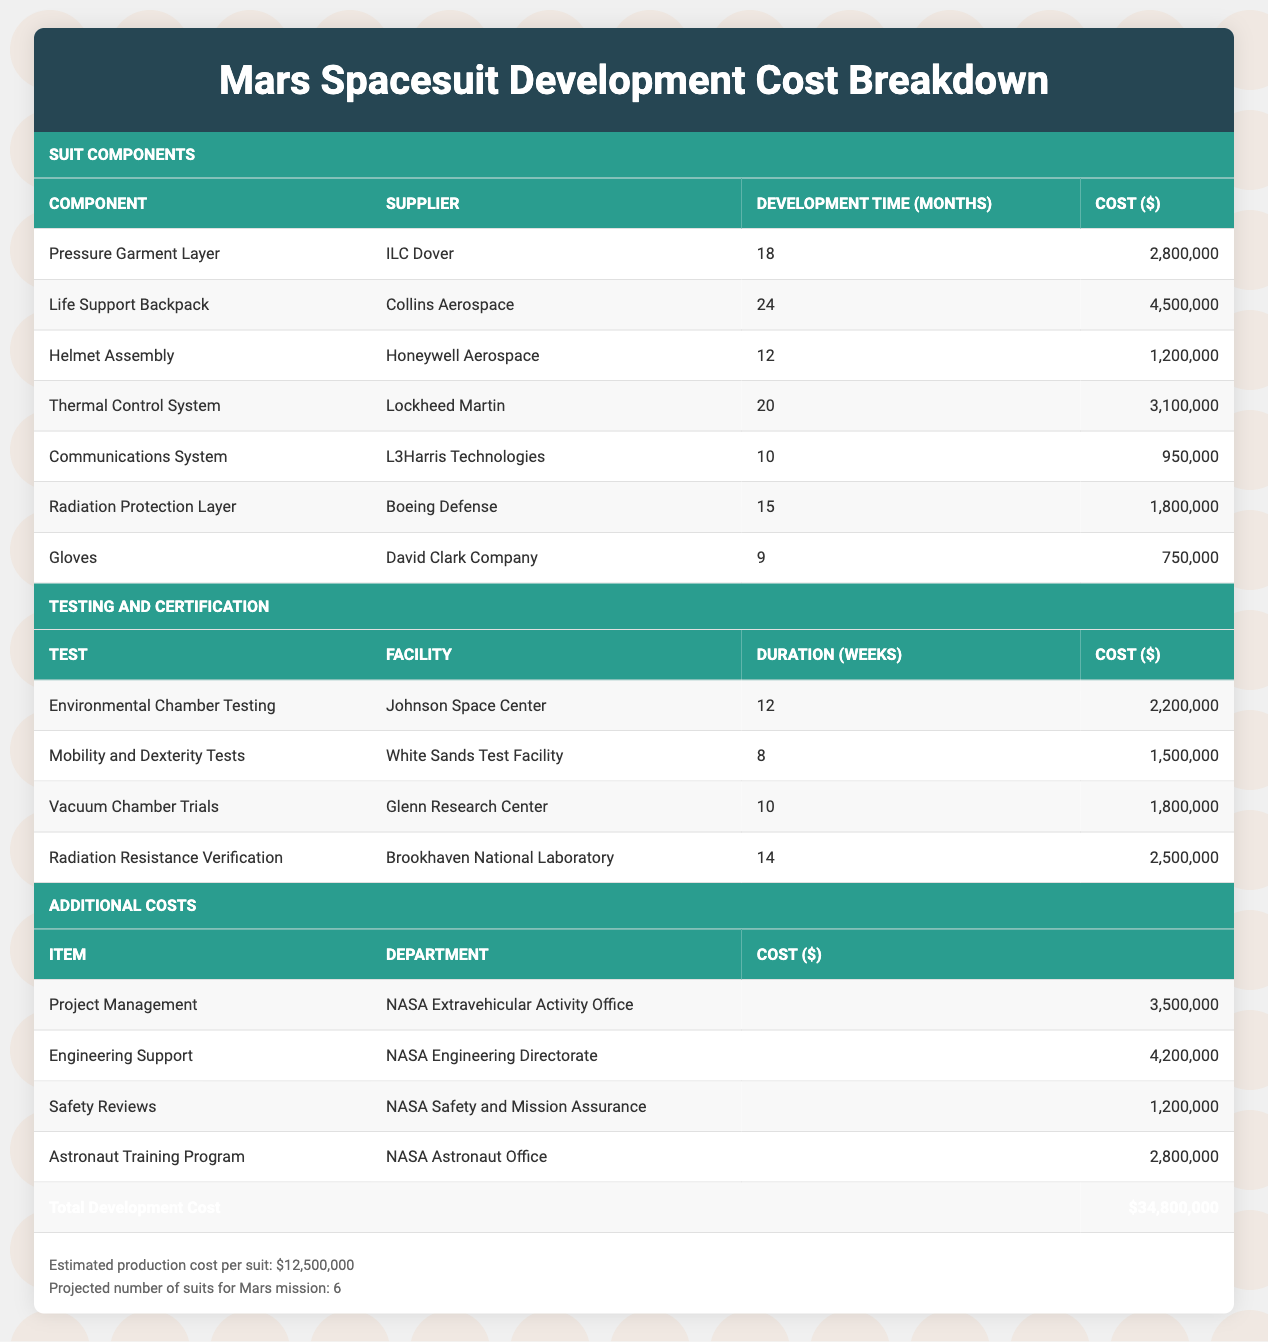What is the total cost of the Pressure Garment Layer? The Pressure Garment Layer has its cost listed in the table as $2,800,000.
Answer: $2,800,000 How long does it take to develop the Life Support Backpack? The development time for the Life Support Backpack is stated in the table as 24 months.
Answer: 24 months What is the cost of the Communications System? The table indicates that the cost of the Communications System is $950,000.
Answer: $950,000 What is the total cost for all suit components? To find the total cost of all suit components, we add the individual costs: $2,800,000 + $4,500,000 + $1,200,000 + $3,100,000 + $950,000 + $1,800,000 + $750,000 = $16,100,000.
Answer: $16,100,000 Is the estimated production cost per suit higher than the total development cost? The estimated production cost per suit is $12,500,000, while the total development cost is $34,800,000. Therefore, the estimated production cost is not higher.
Answer: No What percentage of the total development cost is allocated to R&D for the Helmet Assembly? The cost of the Helmet Assembly is $1,200,000. To find the percentage, calculate ($1,200,000 / $34,800,000) * 100 = 3.44%.
Answer: 3.44% How much does Project Management cost compared to the Life Support Backpack? The Project Management cost is $3,500,000, and the Life Support Backpack costs $4,500,000. The difference is $4,500,000 - $3,500,000 = $1,000,000, meaning Project Management is less expensive by that amount.
Answer: $1,000,000 less What is the average cost of all testing and certification items? The total cost of testing and certification items is $2,200,000 + $1,500,000 + $1,800,000 + $2,500,000 = $8,000,000. There are four items, so the average cost is $8,000,000 / 4 = $2,000,000.
Answer: $2,000,000 How many months in total are required for the development of all components? To find the total months, we sum the development times: 18 + 24 + 12 + 20 + 10 + 15 + 9 = 108 months.
Answer: 108 months 